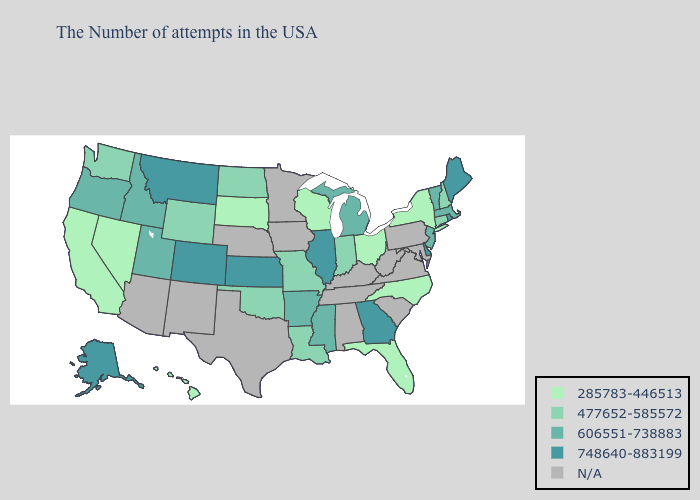Does the first symbol in the legend represent the smallest category?
Keep it brief. Yes. What is the value of Colorado?
Give a very brief answer. 748640-883199. What is the highest value in states that border Washington?
Short answer required. 606551-738883. What is the highest value in the South ?
Answer briefly. 748640-883199. What is the highest value in states that border Arizona?
Keep it brief. 748640-883199. Does California have the lowest value in the West?
Answer briefly. Yes. What is the value of Arizona?
Concise answer only. N/A. What is the lowest value in the USA?
Write a very short answer. 285783-446513. Is the legend a continuous bar?
Keep it brief. No. Is the legend a continuous bar?
Short answer required. No. Which states have the lowest value in the USA?
Quick response, please. New York, North Carolina, Ohio, Florida, Wisconsin, South Dakota, Nevada, California, Hawaii. What is the lowest value in the MidWest?
Write a very short answer. 285783-446513. Among the states that border Indiana , does Ohio have the lowest value?
Answer briefly. Yes. 